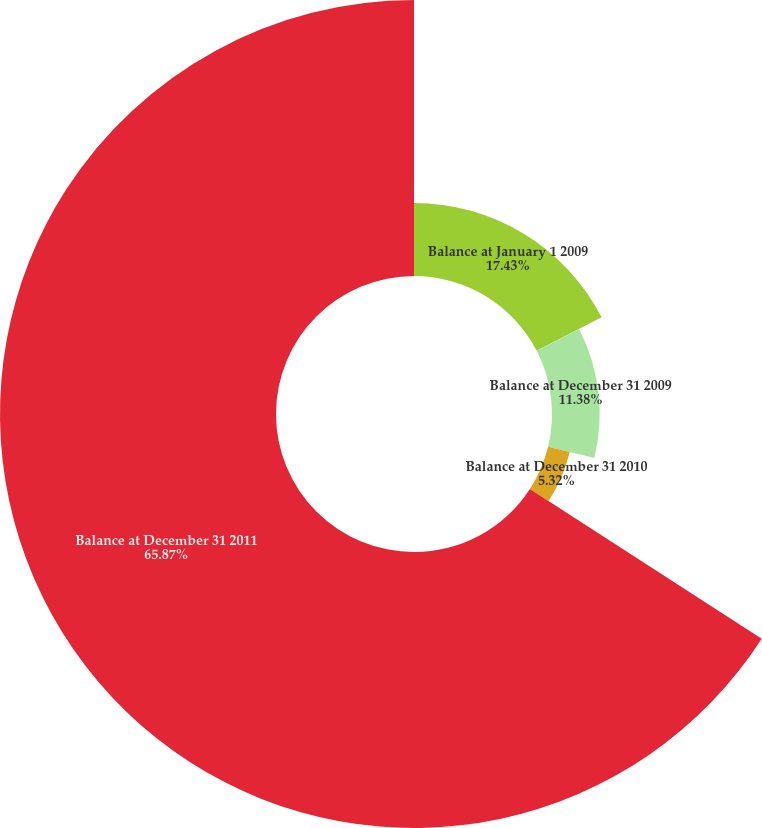<chart> <loc_0><loc_0><loc_500><loc_500><pie_chart><fcel>Balance at January 1 2009<fcel>Balance at December 31 2009<fcel>Balance at December 31 2010<fcel>Balance at December 31 2011<nl><fcel>17.43%<fcel>11.38%<fcel>5.32%<fcel>65.87%<nl></chart> 